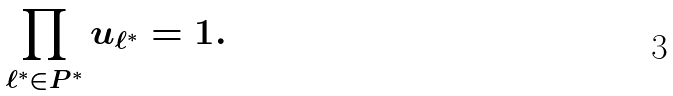<formula> <loc_0><loc_0><loc_500><loc_500>\prod _ { \ell ^ { * } \in P ^ { * } } u _ { \ell ^ { * } } = 1 .</formula> 